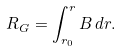Convert formula to latex. <formula><loc_0><loc_0><loc_500><loc_500>R _ { G } = \int _ { r _ { 0 } } ^ { r } B \, d r .</formula> 